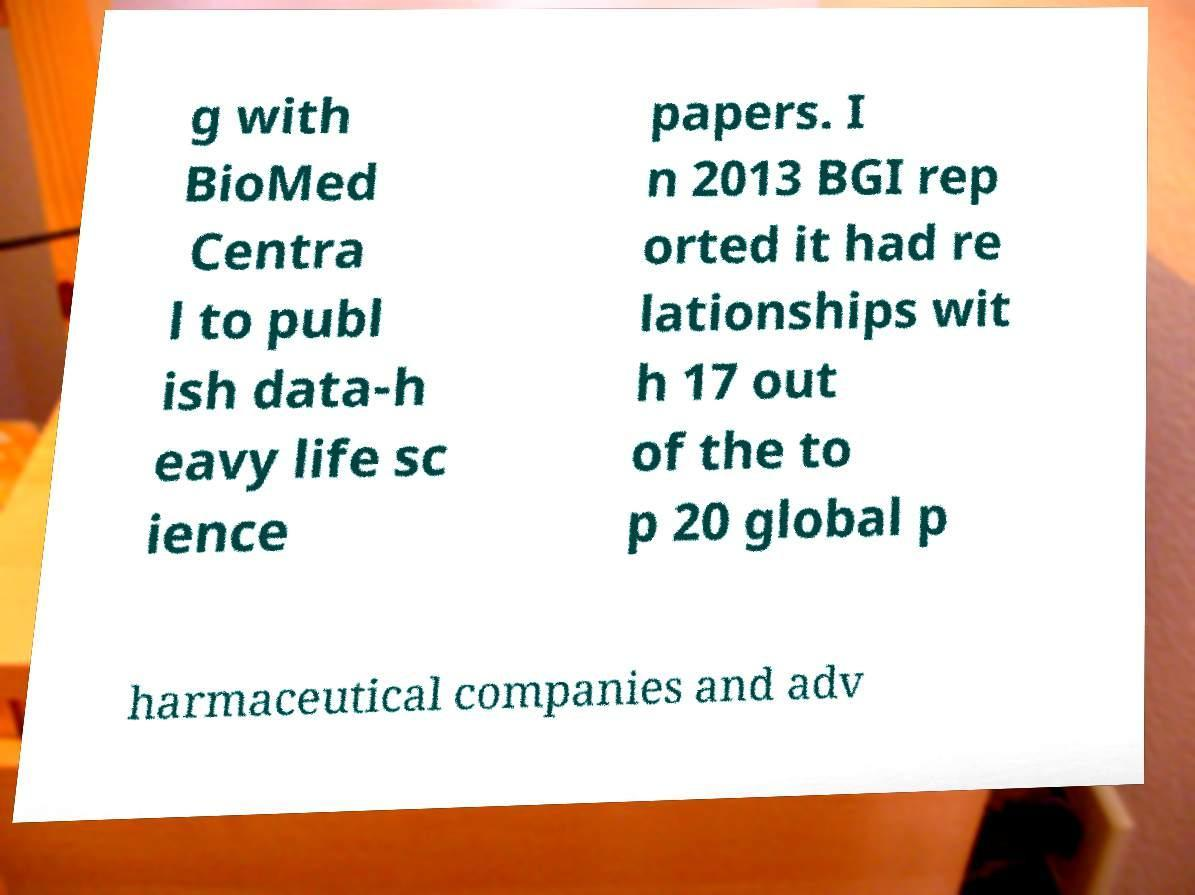Please identify and transcribe the text found in this image. g with BioMed Centra l to publ ish data-h eavy life sc ience papers. I n 2013 BGI rep orted it had re lationships wit h 17 out of the to p 20 global p harmaceutical companies and adv 